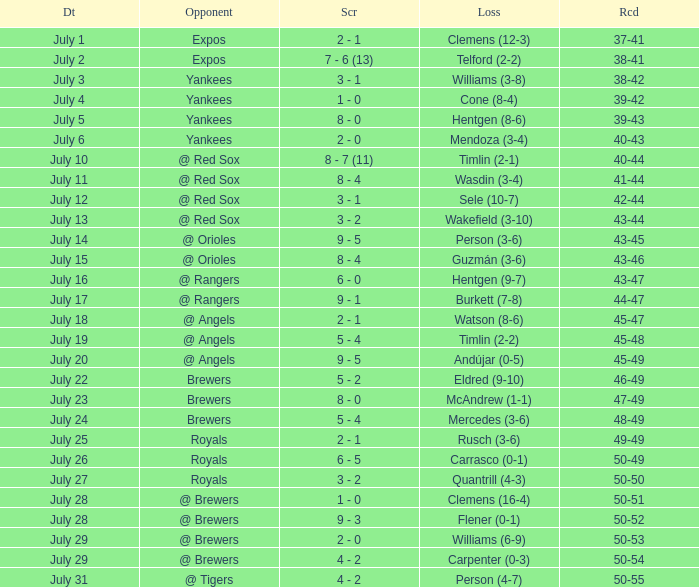What's the record on july 10? 40-44. 